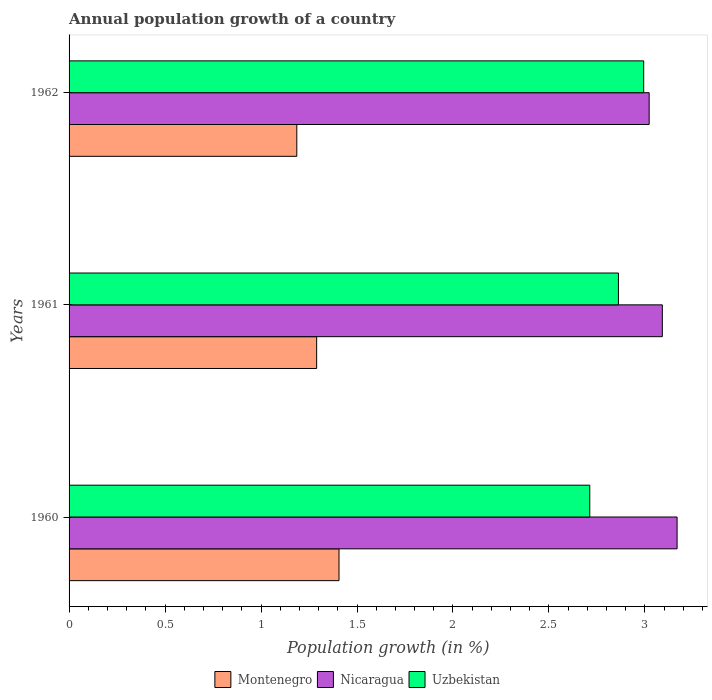How many groups of bars are there?
Offer a very short reply. 3. How many bars are there on the 3rd tick from the top?
Offer a terse response. 3. In how many cases, is the number of bars for a given year not equal to the number of legend labels?
Give a very brief answer. 0. What is the annual population growth in Uzbekistan in 1961?
Keep it short and to the point. 2.86. Across all years, what is the maximum annual population growth in Montenegro?
Provide a succinct answer. 1.41. Across all years, what is the minimum annual population growth in Montenegro?
Make the answer very short. 1.19. In which year was the annual population growth in Uzbekistan maximum?
Provide a succinct answer. 1962. In which year was the annual population growth in Montenegro minimum?
Provide a short and direct response. 1962. What is the total annual population growth in Nicaragua in the graph?
Keep it short and to the point. 9.28. What is the difference between the annual population growth in Montenegro in 1960 and that in 1962?
Provide a succinct answer. 0.22. What is the difference between the annual population growth in Nicaragua in 1962 and the annual population growth in Uzbekistan in 1960?
Offer a terse response. 0.31. What is the average annual population growth in Montenegro per year?
Offer a very short reply. 1.29. In the year 1961, what is the difference between the annual population growth in Uzbekistan and annual population growth in Nicaragua?
Provide a short and direct response. -0.23. In how many years, is the annual population growth in Montenegro greater than 1.1 %?
Ensure brevity in your answer.  3. What is the ratio of the annual population growth in Montenegro in 1960 to that in 1962?
Keep it short and to the point. 1.19. Is the annual population growth in Montenegro in 1960 less than that in 1962?
Provide a short and direct response. No. Is the difference between the annual population growth in Uzbekistan in 1960 and 1962 greater than the difference between the annual population growth in Nicaragua in 1960 and 1962?
Offer a terse response. No. What is the difference between the highest and the second highest annual population growth in Uzbekistan?
Provide a short and direct response. 0.13. What is the difference between the highest and the lowest annual population growth in Nicaragua?
Offer a very short reply. 0.15. In how many years, is the annual population growth in Nicaragua greater than the average annual population growth in Nicaragua taken over all years?
Your response must be concise. 1. What does the 1st bar from the top in 1960 represents?
Ensure brevity in your answer.  Uzbekistan. What does the 1st bar from the bottom in 1960 represents?
Make the answer very short. Montenegro. How many bars are there?
Provide a succinct answer. 9. How many years are there in the graph?
Offer a terse response. 3. What is the difference between two consecutive major ticks on the X-axis?
Give a very brief answer. 0.5. Where does the legend appear in the graph?
Make the answer very short. Bottom center. How are the legend labels stacked?
Provide a short and direct response. Horizontal. What is the title of the graph?
Your answer should be very brief. Annual population growth of a country. What is the label or title of the X-axis?
Provide a short and direct response. Population growth (in %). What is the Population growth (in %) of Montenegro in 1960?
Offer a very short reply. 1.41. What is the Population growth (in %) of Nicaragua in 1960?
Provide a short and direct response. 3.17. What is the Population growth (in %) in Uzbekistan in 1960?
Provide a succinct answer. 2.71. What is the Population growth (in %) of Montenegro in 1961?
Offer a terse response. 1.29. What is the Population growth (in %) in Nicaragua in 1961?
Keep it short and to the point. 3.09. What is the Population growth (in %) of Uzbekistan in 1961?
Your answer should be compact. 2.86. What is the Population growth (in %) of Montenegro in 1962?
Your response must be concise. 1.19. What is the Population growth (in %) of Nicaragua in 1962?
Make the answer very short. 3.02. What is the Population growth (in %) in Uzbekistan in 1962?
Ensure brevity in your answer.  2.99. Across all years, what is the maximum Population growth (in %) in Montenegro?
Provide a succinct answer. 1.41. Across all years, what is the maximum Population growth (in %) of Nicaragua?
Your answer should be compact. 3.17. Across all years, what is the maximum Population growth (in %) of Uzbekistan?
Provide a short and direct response. 2.99. Across all years, what is the minimum Population growth (in %) of Montenegro?
Your response must be concise. 1.19. Across all years, what is the minimum Population growth (in %) of Nicaragua?
Offer a very short reply. 3.02. Across all years, what is the minimum Population growth (in %) of Uzbekistan?
Your answer should be compact. 2.71. What is the total Population growth (in %) of Montenegro in the graph?
Give a very brief answer. 3.88. What is the total Population growth (in %) of Nicaragua in the graph?
Offer a very short reply. 9.28. What is the total Population growth (in %) of Uzbekistan in the graph?
Offer a very short reply. 8.57. What is the difference between the Population growth (in %) in Montenegro in 1960 and that in 1961?
Offer a terse response. 0.12. What is the difference between the Population growth (in %) in Nicaragua in 1960 and that in 1961?
Provide a short and direct response. 0.08. What is the difference between the Population growth (in %) in Uzbekistan in 1960 and that in 1961?
Provide a short and direct response. -0.15. What is the difference between the Population growth (in %) of Montenegro in 1960 and that in 1962?
Ensure brevity in your answer.  0.22. What is the difference between the Population growth (in %) of Nicaragua in 1960 and that in 1962?
Provide a short and direct response. 0.15. What is the difference between the Population growth (in %) of Uzbekistan in 1960 and that in 1962?
Keep it short and to the point. -0.28. What is the difference between the Population growth (in %) of Montenegro in 1961 and that in 1962?
Offer a terse response. 0.1. What is the difference between the Population growth (in %) of Nicaragua in 1961 and that in 1962?
Your answer should be very brief. 0.07. What is the difference between the Population growth (in %) in Uzbekistan in 1961 and that in 1962?
Provide a short and direct response. -0.13. What is the difference between the Population growth (in %) of Montenegro in 1960 and the Population growth (in %) of Nicaragua in 1961?
Offer a terse response. -1.68. What is the difference between the Population growth (in %) in Montenegro in 1960 and the Population growth (in %) in Uzbekistan in 1961?
Offer a very short reply. -1.46. What is the difference between the Population growth (in %) in Nicaragua in 1960 and the Population growth (in %) in Uzbekistan in 1961?
Offer a very short reply. 0.31. What is the difference between the Population growth (in %) of Montenegro in 1960 and the Population growth (in %) of Nicaragua in 1962?
Provide a short and direct response. -1.62. What is the difference between the Population growth (in %) of Montenegro in 1960 and the Population growth (in %) of Uzbekistan in 1962?
Ensure brevity in your answer.  -1.59. What is the difference between the Population growth (in %) of Nicaragua in 1960 and the Population growth (in %) of Uzbekistan in 1962?
Your answer should be very brief. 0.17. What is the difference between the Population growth (in %) of Montenegro in 1961 and the Population growth (in %) of Nicaragua in 1962?
Offer a very short reply. -1.73. What is the difference between the Population growth (in %) of Montenegro in 1961 and the Population growth (in %) of Uzbekistan in 1962?
Your answer should be very brief. -1.7. What is the difference between the Population growth (in %) of Nicaragua in 1961 and the Population growth (in %) of Uzbekistan in 1962?
Your response must be concise. 0.1. What is the average Population growth (in %) in Montenegro per year?
Offer a very short reply. 1.29. What is the average Population growth (in %) of Nicaragua per year?
Your response must be concise. 3.09. What is the average Population growth (in %) of Uzbekistan per year?
Make the answer very short. 2.86. In the year 1960, what is the difference between the Population growth (in %) in Montenegro and Population growth (in %) in Nicaragua?
Ensure brevity in your answer.  -1.76. In the year 1960, what is the difference between the Population growth (in %) of Montenegro and Population growth (in %) of Uzbekistan?
Ensure brevity in your answer.  -1.31. In the year 1960, what is the difference between the Population growth (in %) of Nicaragua and Population growth (in %) of Uzbekistan?
Your response must be concise. 0.45. In the year 1961, what is the difference between the Population growth (in %) in Montenegro and Population growth (in %) in Nicaragua?
Give a very brief answer. -1.8. In the year 1961, what is the difference between the Population growth (in %) in Montenegro and Population growth (in %) in Uzbekistan?
Make the answer very short. -1.57. In the year 1961, what is the difference between the Population growth (in %) of Nicaragua and Population growth (in %) of Uzbekistan?
Provide a succinct answer. 0.23. In the year 1962, what is the difference between the Population growth (in %) in Montenegro and Population growth (in %) in Nicaragua?
Offer a terse response. -1.84. In the year 1962, what is the difference between the Population growth (in %) in Montenegro and Population growth (in %) in Uzbekistan?
Keep it short and to the point. -1.81. In the year 1962, what is the difference between the Population growth (in %) in Nicaragua and Population growth (in %) in Uzbekistan?
Offer a very short reply. 0.03. What is the ratio of the Population growth (in %) in Montenegro in 1960 to that in 1961?
Give a very brief answer. 1.09. What is the ratio of the Population growth (in %) in Nicaragua in 1960 to that in 1961?
Offer a very short reply. 1.02. What is the ratio of the Population growth (in %) of Uzbekistan in 1960 to that in 1961?
Provide a succinct answer. 0.95. What is the ratio of the Population growth (in %) in Montenegro in 1960 to that in 1962?
Your answer should be compact. 1.19. What is the ratio of the Population growth (in %) in Nicaragua in 1960 to that in 1962?
Offer a very short reply. 1.05. What is the ratio of the Population growth (in %) in Uzbekistan in 1960 to that in 1962?
Offer a very short reply. 0.91. What is the ratio of the Population growth (in %) in Montenegro in 1961 to that in 1962?
Offer a terse response. 1.09. What is the ratio of the Population growth (in %) in Nicaragua in 1961 to that in 1962?
Your answer should be compact. 1.02. What is the ratio of the Population growth (in %) in Uzbekistan in 1961 to that in 1962?
Provide a short and direct response. 0.96. What is the difference between the highest and the second highest Population growth (in %) of Montenegro?
Provide a succinct answer. 0.12. What is the difference between the highest and the second highest Population growth (in %) of Nicaragua?
Give a very brief answer. 0.08. What is the difference between the highest and the second highest Population growth (in %) in Uzbekistan?
Your answer should be compact. 0.13. What is the difference between the highest and the lowest Population growth (in %) of Montenegro?
Your response must be concise. 0.22. What is the difference between the highest and the lowest Population growth (in %) in Nicaragua?
Your answer should be compact. 0.15. What is the difference between the highest and the lowest Population growth (in %) of Uzbekistan?
Your answer should be very brief. 0.28. 